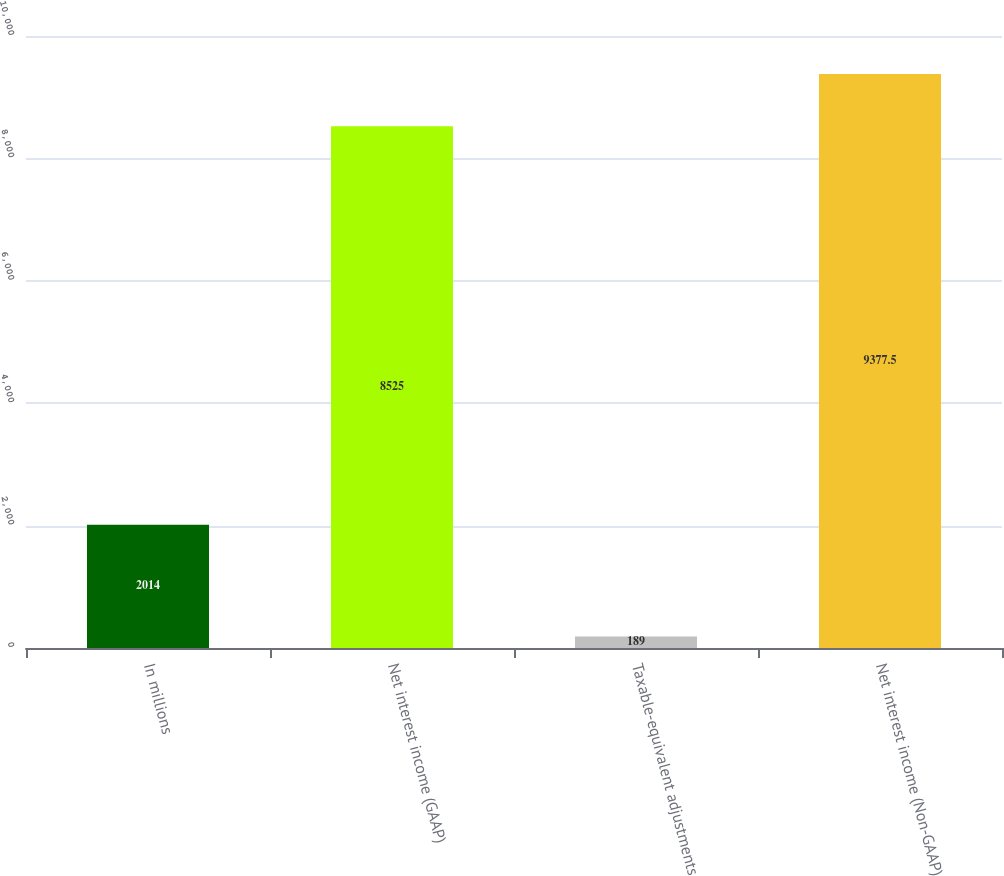Convert chart to OTSL. <chart><loc_0><loc_0><loc_500><loc_500><bar_chart><fcel>In millions<fcel>Net interest income (GAAP)<fcel>Taxable-equivalent adjustments<fcel>Net interest income (Non-GAAP)<nl><fcel>2014<fcel>8525<fcel>189<fcel>9377.5<nl></chart> 